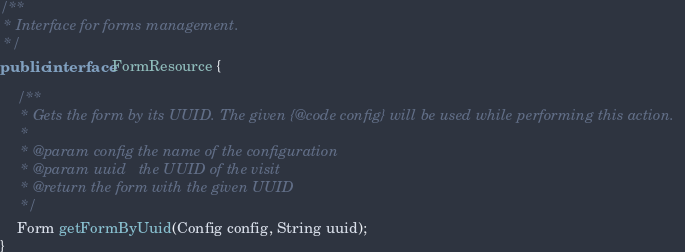Convert code to text. <code><loc_0><loc_0><loc_500><loc_500><_Java_>/**
 * Interface for forms management.
 */
public interface FormResource {

    /**
     * Gets the form by its UUID. The given {@code config} will be used while performing this action.
     *
     * @param config the name of the configuration
     * @param uuid   the UUID of the visit
     * @return the form with the given UUID
     */
    Form getFormByUuid(Config config, String uuid);
}
</code> 